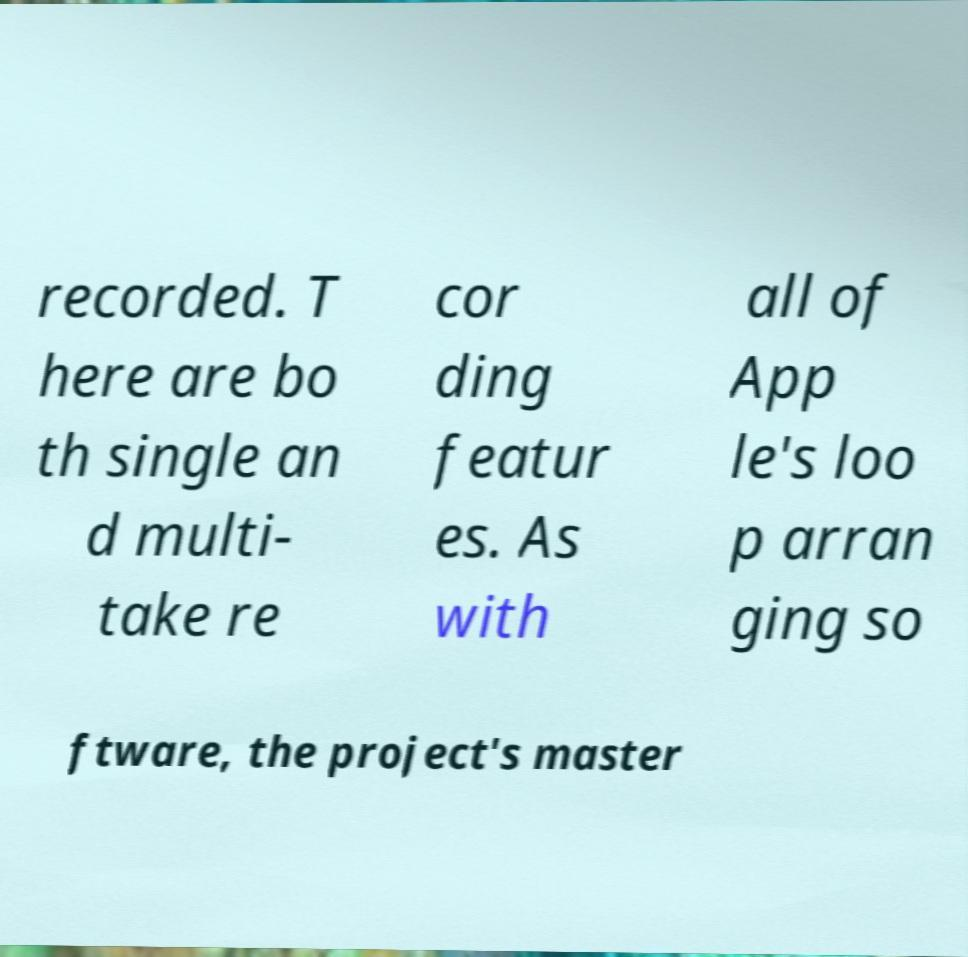I need the written content from this picture converted into text. Can you do that? recorded. T here are bo th single an d multi- take re cor ding featur es. As with all of App le's loo p arran ging so ftware, the project's master 